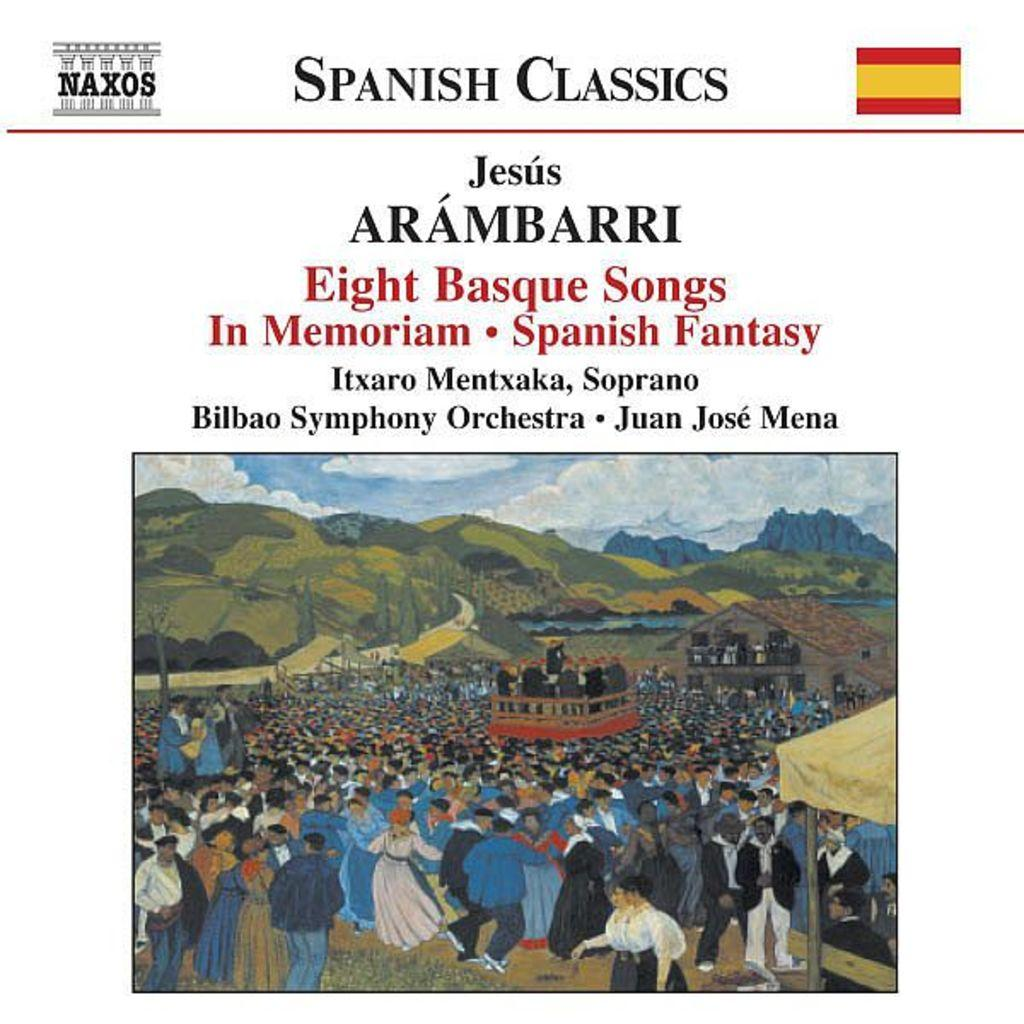What type of visual is the image? The image is a poster. What can be found on the poster besides visual elements? There are words on the poster. How many symbols are present on the poster? There are two symbols on the poster. Is there any photographic content on the poster? Yes, there is a photo on the poster. What type of bear can be seen interacting with the symbols on the poster? There is no bear present on the poster; it only contains words, symbols, and a photo. 